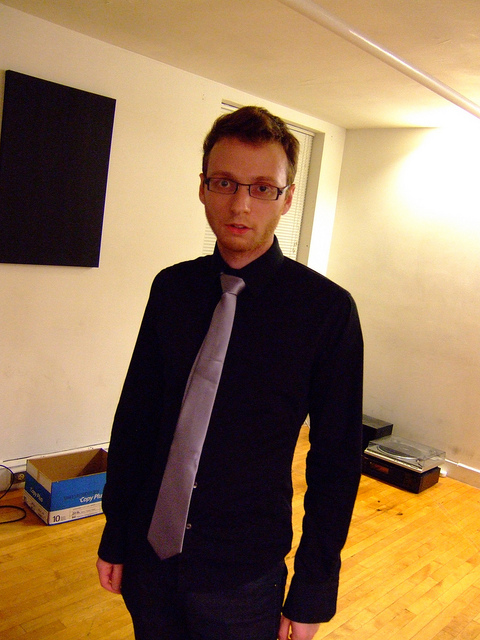What might explain the lack of furniture here? It appears that the individual in the image might be in the process of moving. Items are packed in boxes, typically indicating a transition from one location to another. While it's possible that other scenarios, such as poverty or a recent robbery, could explain the lack of furniture, the presence of moving boxes suggests that moving is the most likely explanation. 